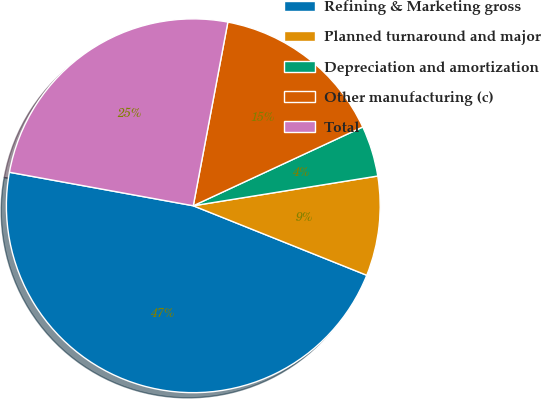<chart> <loc_0><loc_0><loc_500><loc_500><pie_chart><fcel>Refining & Marketing gross<fcel>Planned turnaround and major<fcel>Depreciation and amortization<fcel>Other manufacturing (c)<fcel>Total<nl><fcel>46.8%<fcel>8.61%<fcel>4.38%<fcel>15.11%<fcel>25.09%<nl></chart> 